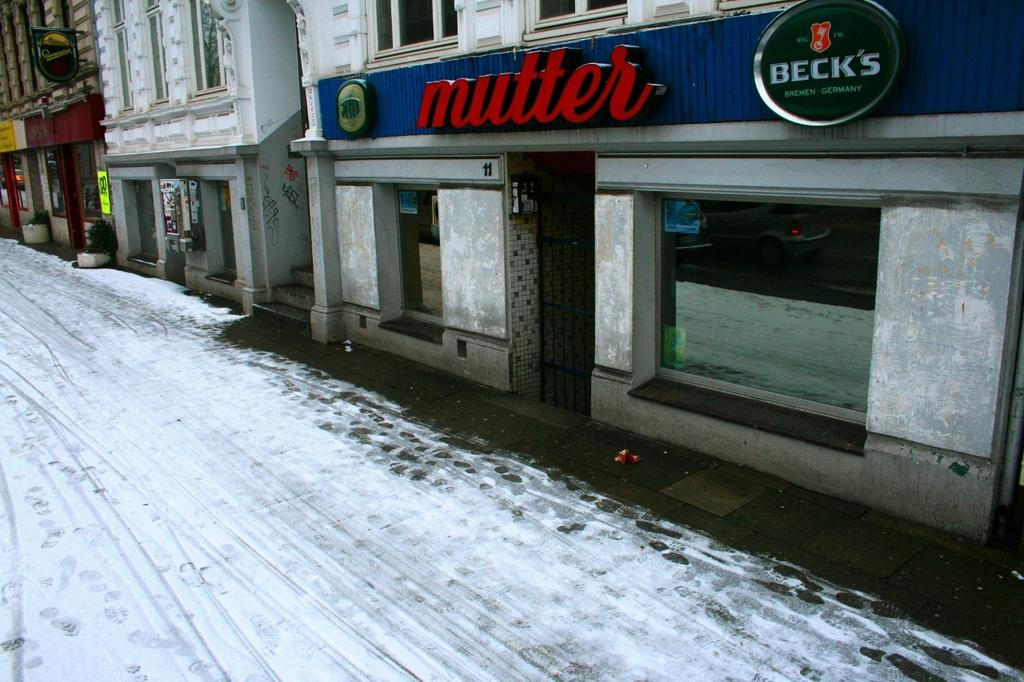What is covering the road in the image? There is snow on the road in the image. What type of structures can be seen in the image? There are stalls and buildings in the image. How can the locations be identified in the image? There are name boards in the image. What type of plant is present in the image? There is a house plant in the image. What type of mint is being used to flavor the snow in the image? There is no mint or flavoring present in the image; it simply shows snow on the road. Can you see a baseball game happening in the image? There is no baseball game or any reference to sports in the image. 